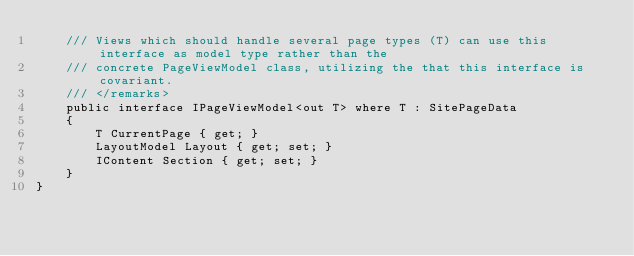<code> <loc_0><loc_0><loc_500><loc_500><_C#_>    /// Views which should handle several page types (T) can use this interface as model type rather than the
    /// concrete PageViewModel class, utilizing the that this interface is covariant.
    /// </remarks>
    public interface IPageViewModel<out T> where T : SitePageData
    {
        T CurrentPage { get; }
        LayoutModel Layout { get; set; }
        IContent Section { get; set; }
    }
}
</code> 